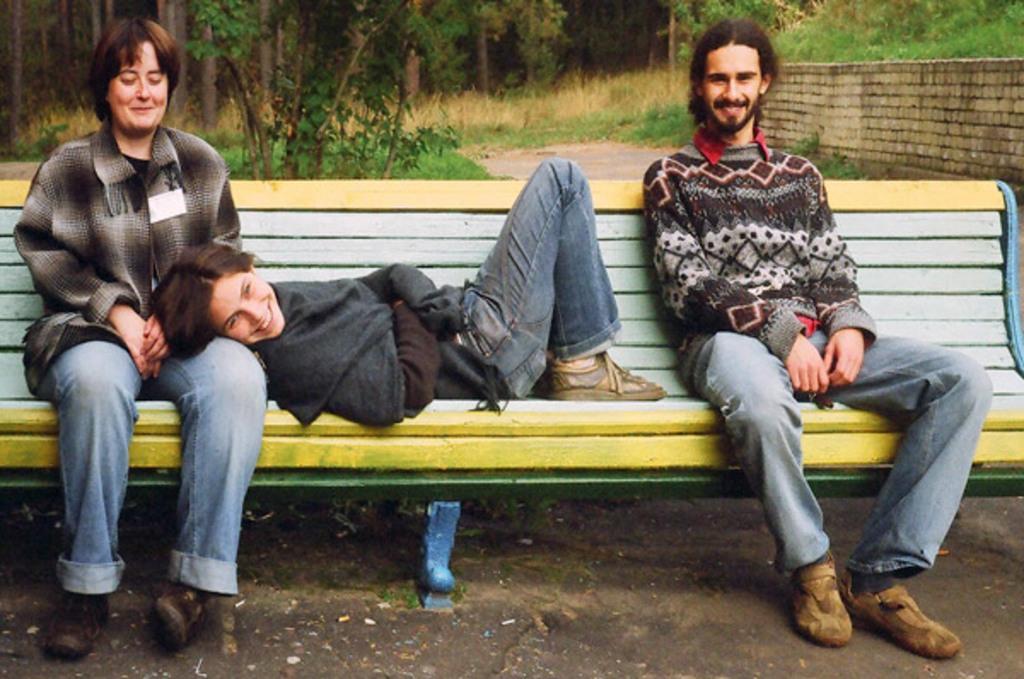In one or two sentences, can you explain what this image depicts? On the left a woman is sitting on the bench. Middle a girl is sleeping on her. At the right a man is sitting in the bench and smiling there is a wall and trees. 